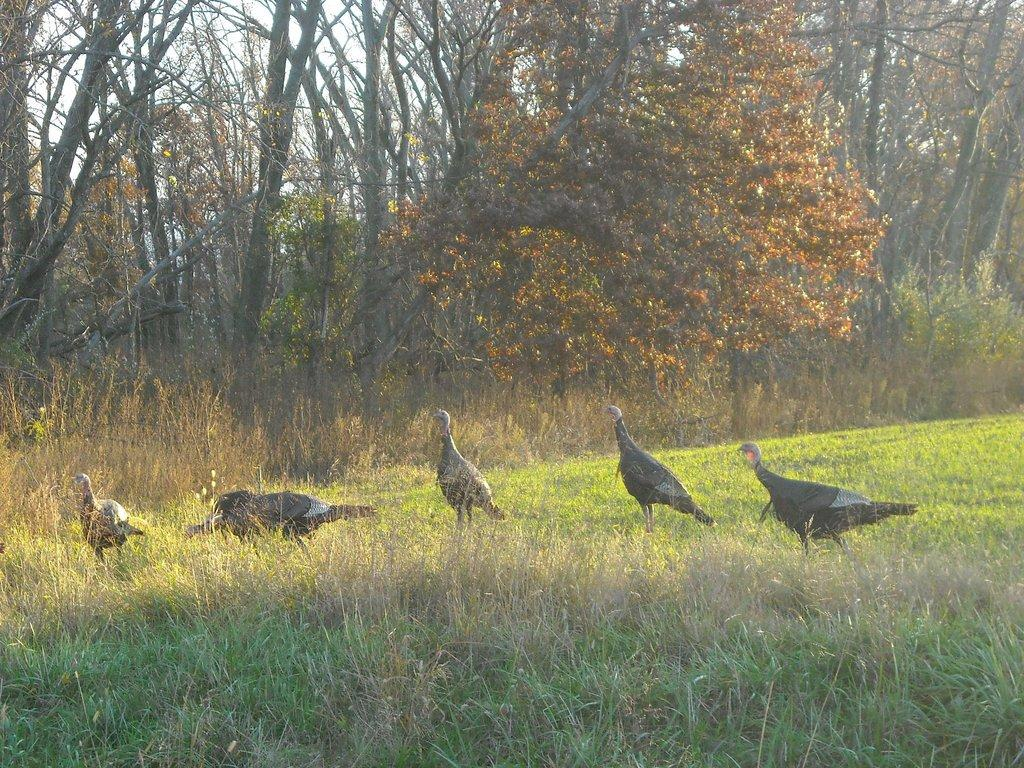How many turkey hens are in the picture? There are five turkey hens in the picture. What type of vegetation is visible at the bottom of the picture? There is grass visible at the bottom of the picture. What can be seen in the background of the picture? There are trees in the background of the picture. What type of polish is being applied to the wrench in the picture? There is no wrench or polish present in the picture; it features five turkey hens, grass, and trees. 